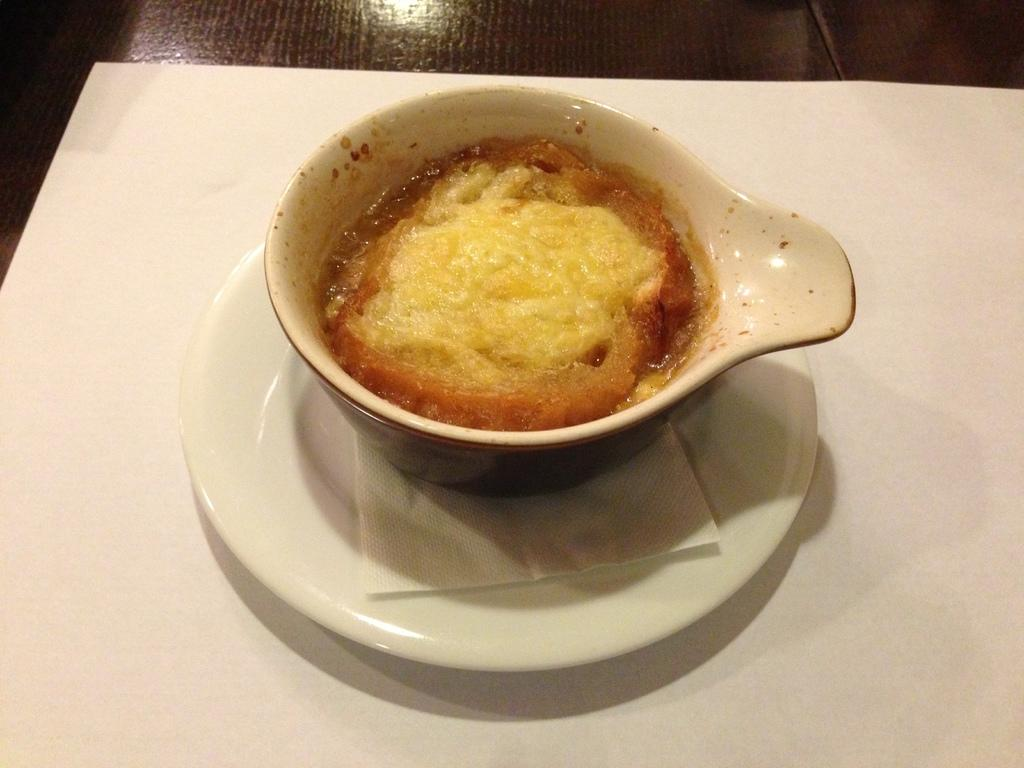What is in the cup that is visible in the image? There is food in the cup that is visible in the image. What other object can be seen on the table in the image? There is a plate in the image. What type of material is present for cleaning or wiping in the image? Tissue paper is present in the image for cleaning or wiping. Where are these objects located in the image? All of these objects are on a table in the image. What part of the room can be seen below the table in the image? The floor is visible in the image. How many girls are in the prison depicted in the image? There is no prison or girls present in the image; it features a cup with food, a plate, tissue paper, and a table. What is the relation between the girls in the image? There are no girls present in the image, so there is no relation to discuss. 